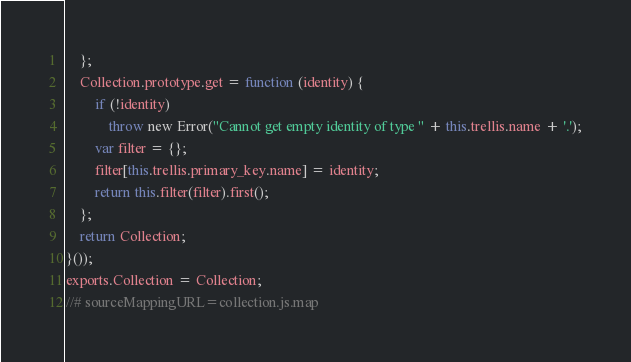<code> <loc_0><loc_0><loc_500><loc_500><_JavaScript_>    };
    Collection.prototype.get = function (identity) {
        if (!identity)
            throw new Error("Cannot get empty identity of type " + this.trellis.name + '.');
        var filter = {};
        filter[this.trellis.primary_key.name] = identity;
        return this.filter(filter).first();
    };
    return Collection;
}());
exports.Collection = Collection;
//# sourceMappingURL=collection.js.map</code> 